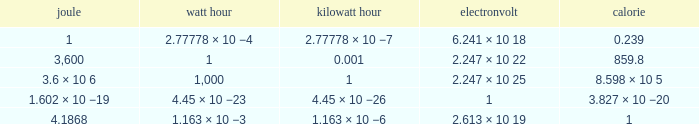What is the equivalent of 3,600 joules in electronvolts? 2.247 × 10 22. 